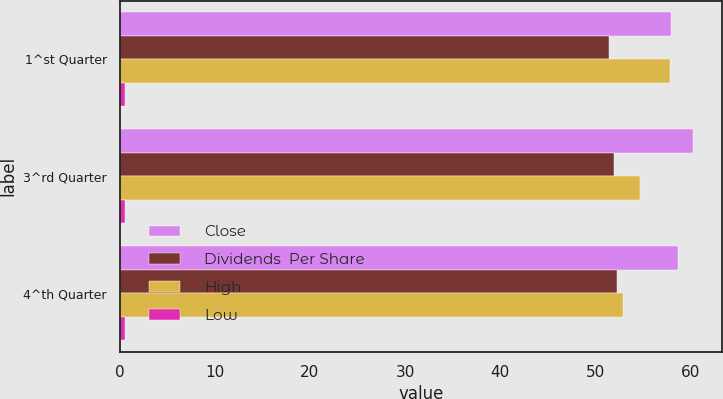<chart> <loc_0><loc_0><loc_500><loc_500><stacked_bar_chart><ecel><fcel>1^st Quarter<fcel>3^rd Quarter<fcel>4^th Quarter<nl><fcel>Close<fcel>57.96<fcel>60.33<fcel>58.7<nl><fcel>Dividends  Per Share<fcel>51.5<fcel>52.03<fcel>52.32<nl><fcel>High<fcel>57.89<fcel>54.74<fcel>52.92<nl><fcel>Low<fcel>0.55<fcel>0.55<fcel>0.57<nl></chart> 